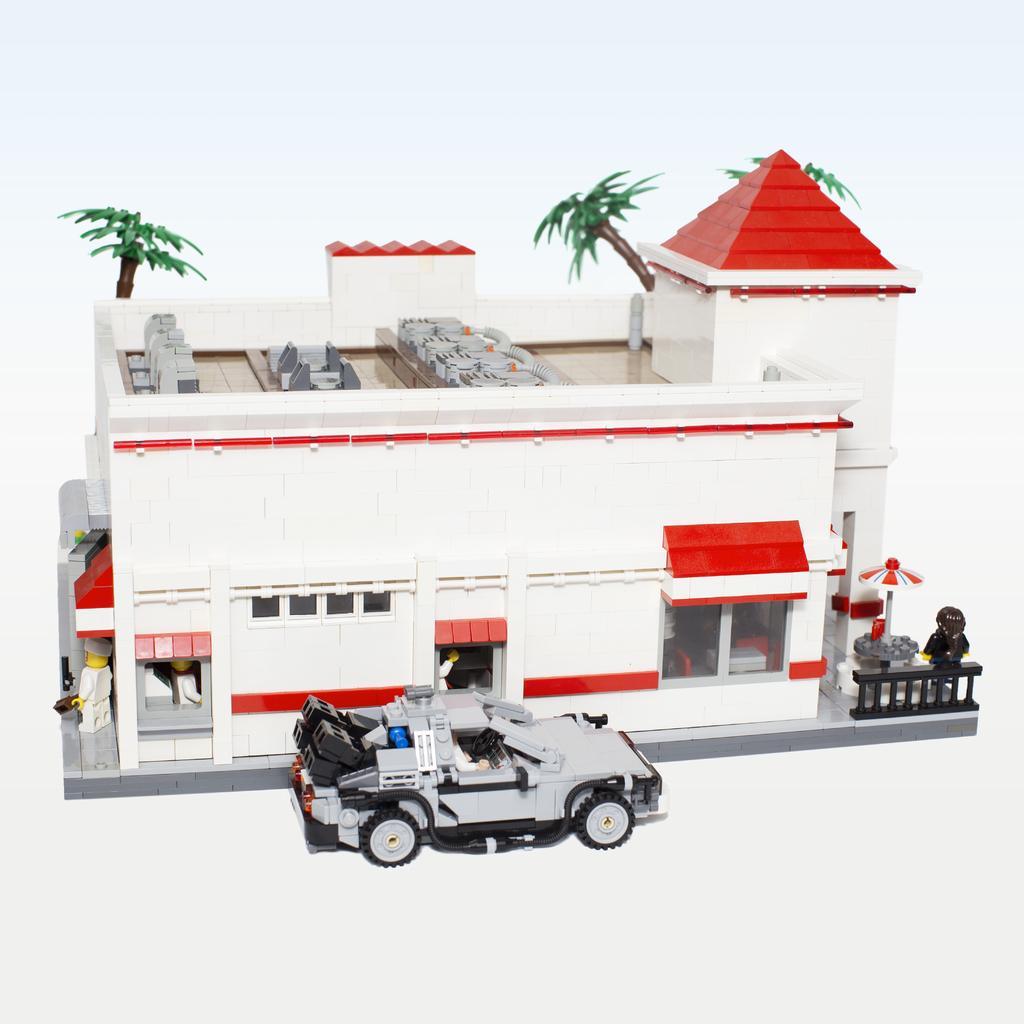Please provide a concise description of this image. In this image there is a toy house where the roof of the house is red in color and it also has coconut trees which are coming from this roof and at the top of the house there are also some chairs to be seated and in front of the house there is a car it is also a toy and towards the left of the house there is a toy of a person and towards right there is another person and there is also a umbrella it is also a toy. 